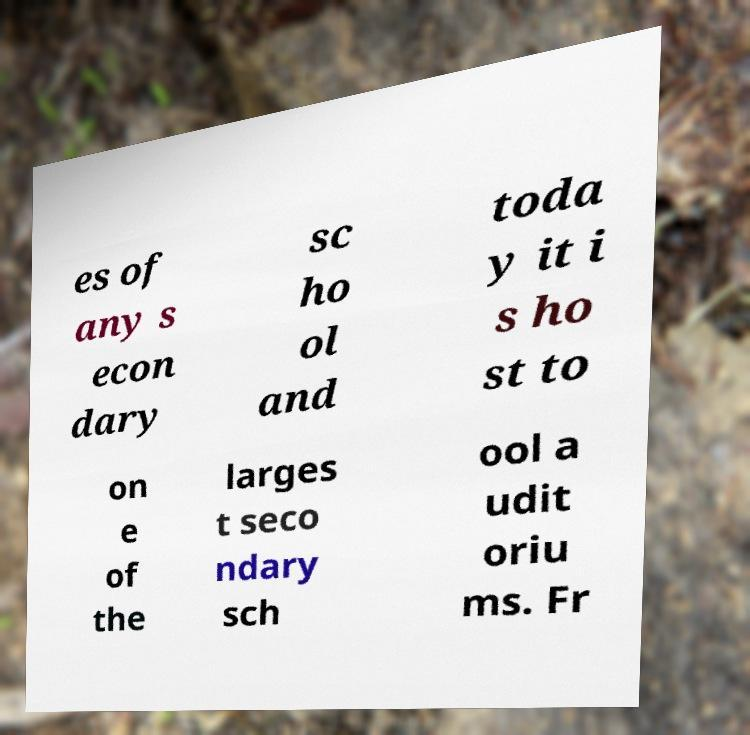What messages or text are displayed in this image? I need them in a readable, typed format. es of any s econ dary sc ho ol and toda y it i s ho st to on e of the larges t seco ndary sch ool a udit oriu ms. Fr 